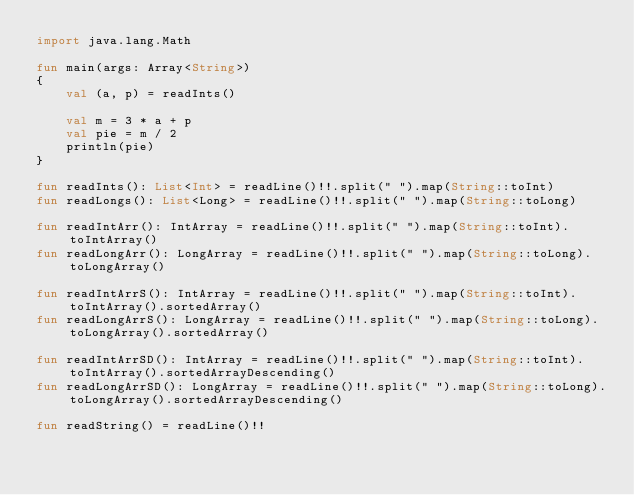Convert code to text. <code><loc_0><loc_0><loc_500><loc_500><_Kotlin_>import java.lang.Math

fun main(args: Array<String>)
{
    val (a, p) = readInts()

    val m = 3 * a + p
    val pie = m / 2
    println(pie)
}

fun readInts(): List<Int> = readLine()!!.split(" ").map(String::toInt)
fun readLongs(): List<Long> = readLine()!!.split(" ").map(String::toLong)

fun readIntArr(): IntArray = readLine()!!.split(" ").map(String::toInt).toIntArray()
fun readLongArr(): LongArray = readLine()!!.split(" ").map(String::toLong).toLongArray()

fun readIntArrS(): IntArray = readLine()!!.split(" ").map(String::toInt).toIntArray().sortedArray()
fun readLongArrS(): LongArray = readLine()!!.split(" ").map(String::toLong).toLongArray().sortedArray()

fun readIntArrSD(): IntArray = readLine()!!.split(" ").map(String::toInt).toIntArray().sortedArrayDescending()
fun readLongArrSD(): LongArray = readLine()!!.split(" ").map(String::toLong).toLongArray().sortedArrayDescending()

fun readString() = readLine()!!
</code> 